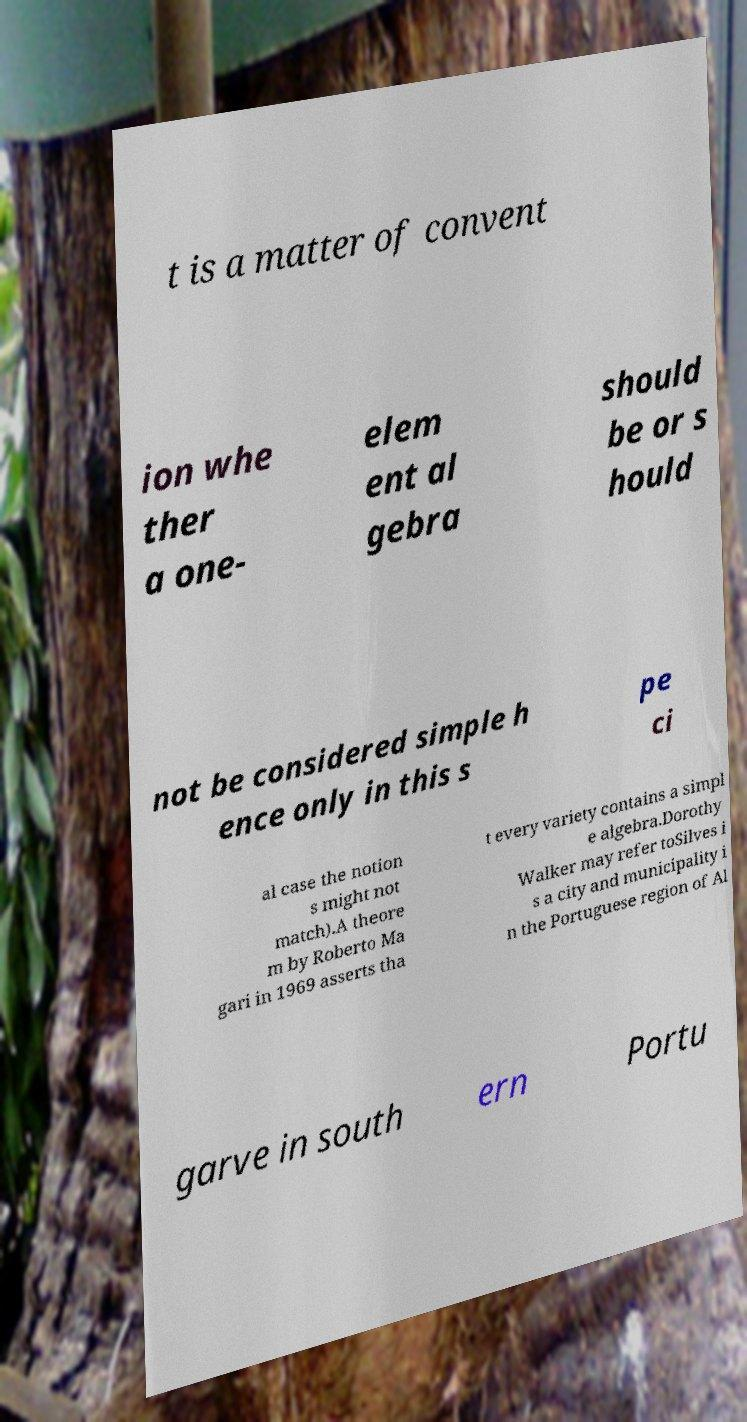What messages or text are displayed in this image? I need them in a readable, typed format. t is a matter of convent ion whe ther a one- elem ent al gebra should be or s hould not be considered simple h ence only in this s pe ci al case the notion s might not match).A theore m by Roberto Ma gari in 1969 asserts tha t every variety contains a simpl e algebra.Dorothy Walker may refer toSilves i s a city and municipality i n the Portuguese region of Al garve in south ern Portu 